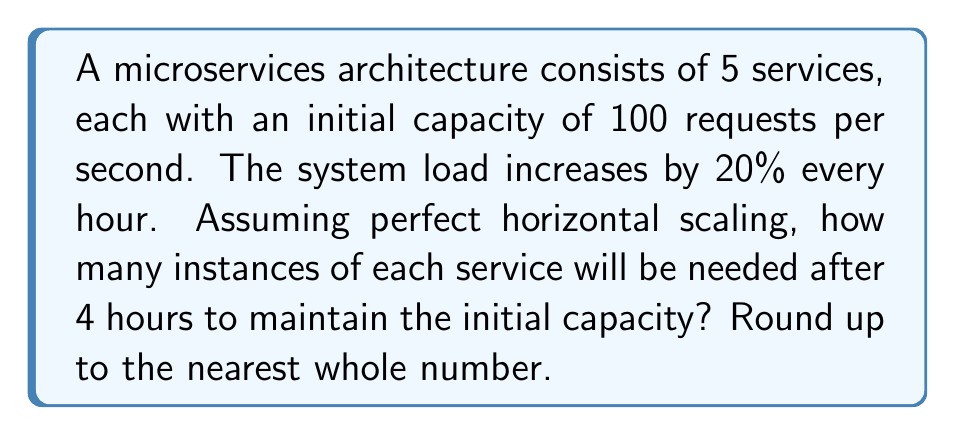Solve this math problem. Let's approach this step-by-step:

1) First, we need to calculate the load increase after 4 hours:
   Initial load: 100%
   Increase per hour: 20%
   Number of hours: 4
   
   Load after 4 hours = $100\% \times (1 + 0.2)^4 = 100\% \times 1.2^4$

2) Calculate $1.2^4$:
   $$1.2^4 = 1.2 \times 1.2 \times 1.2 \times 1.2 = 2.0736$$

3) So, the load after 4 hours will be:
   $100\% \times 2.0736 = 207.36\%$

4) This means the load has increased by 107.36%

5) To maintain the initial capacity, we need to scale the number of instances proportionally to the load increase:
   Number of instances = $\lceil\frac{207.36}{100}\rceil = \lceil2.0736\rceil = 3$

   Where $\lceil \rceil$ represents the ceiling function (rounding up to the nearest whole number).

6) This applies to each of the 5 services in the architecture.
Answer: 3 instances per service 